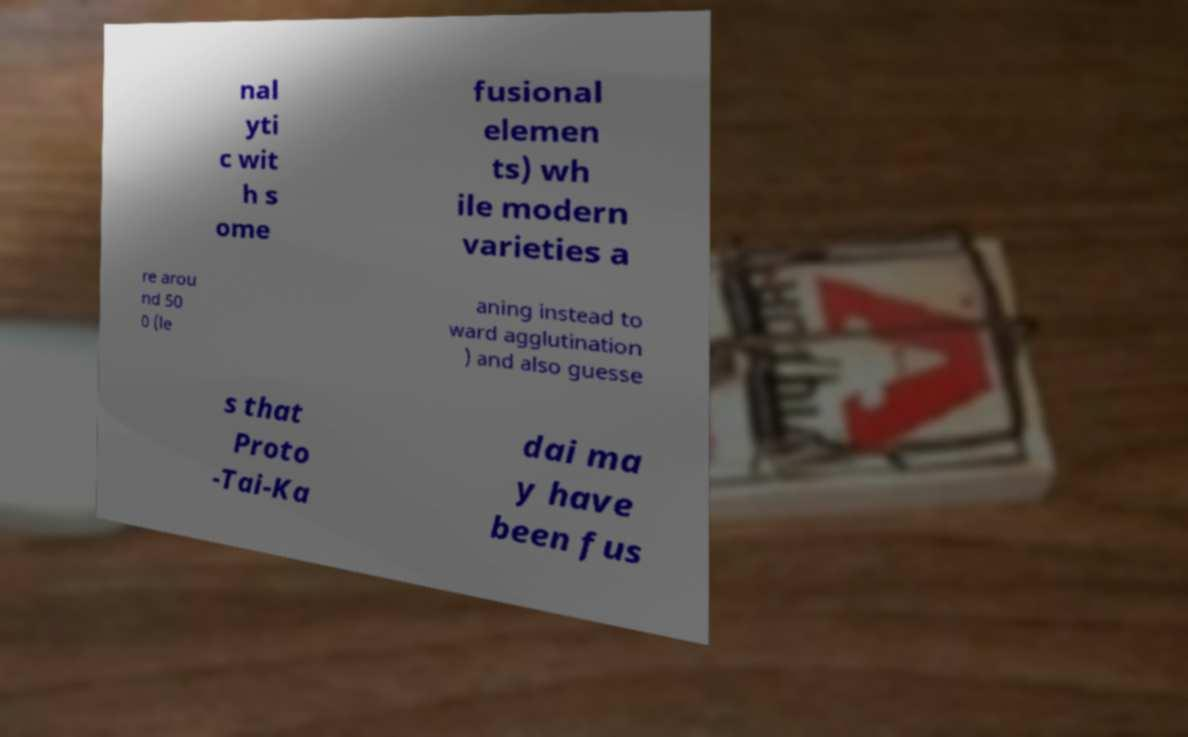Could you extract and type out the text from this image? nal yti c wit h s ome fusional elemen ts) wh ile modern varieties a re arou nd 50 0 (le aning instead to ward agglutination ) and also guesse s that Proto -Tai-Ka dai ma y have been fus 